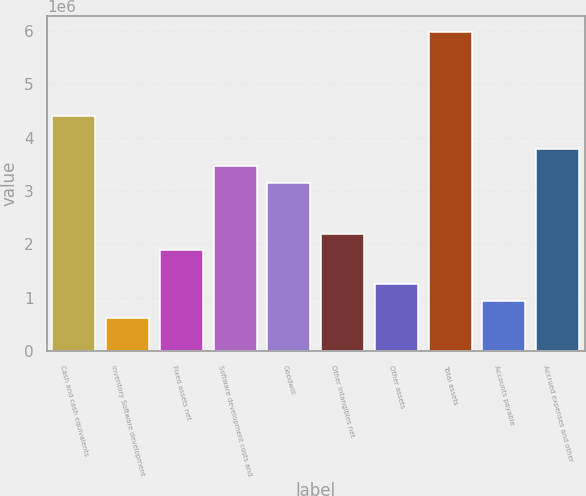<chart> <loc_0><loc_0><loc_500><loc_500><bar_chart><fcel>Cash and cash equivalents<fcel>Inventory Software development<fcel>Fixed assets net<fcel>Software development costs and<fcel>Goodwill<fcel>Other intangibles net<fcel>Other assets<fcel>Total assets<fcel>Accounts payable<fcel>Accrued expenses and other<nl><fcel>4.40834e+06<fcel>630789<fcel>1.88997e+06<fcel>3.46395e+06<fcel>3.14915e+06<fcel>2.20477e+06<fcel>1.26038e+06<fcel>5.98231e+06<fcel>945585<fcel>3.77875e+06<nl></chart> 